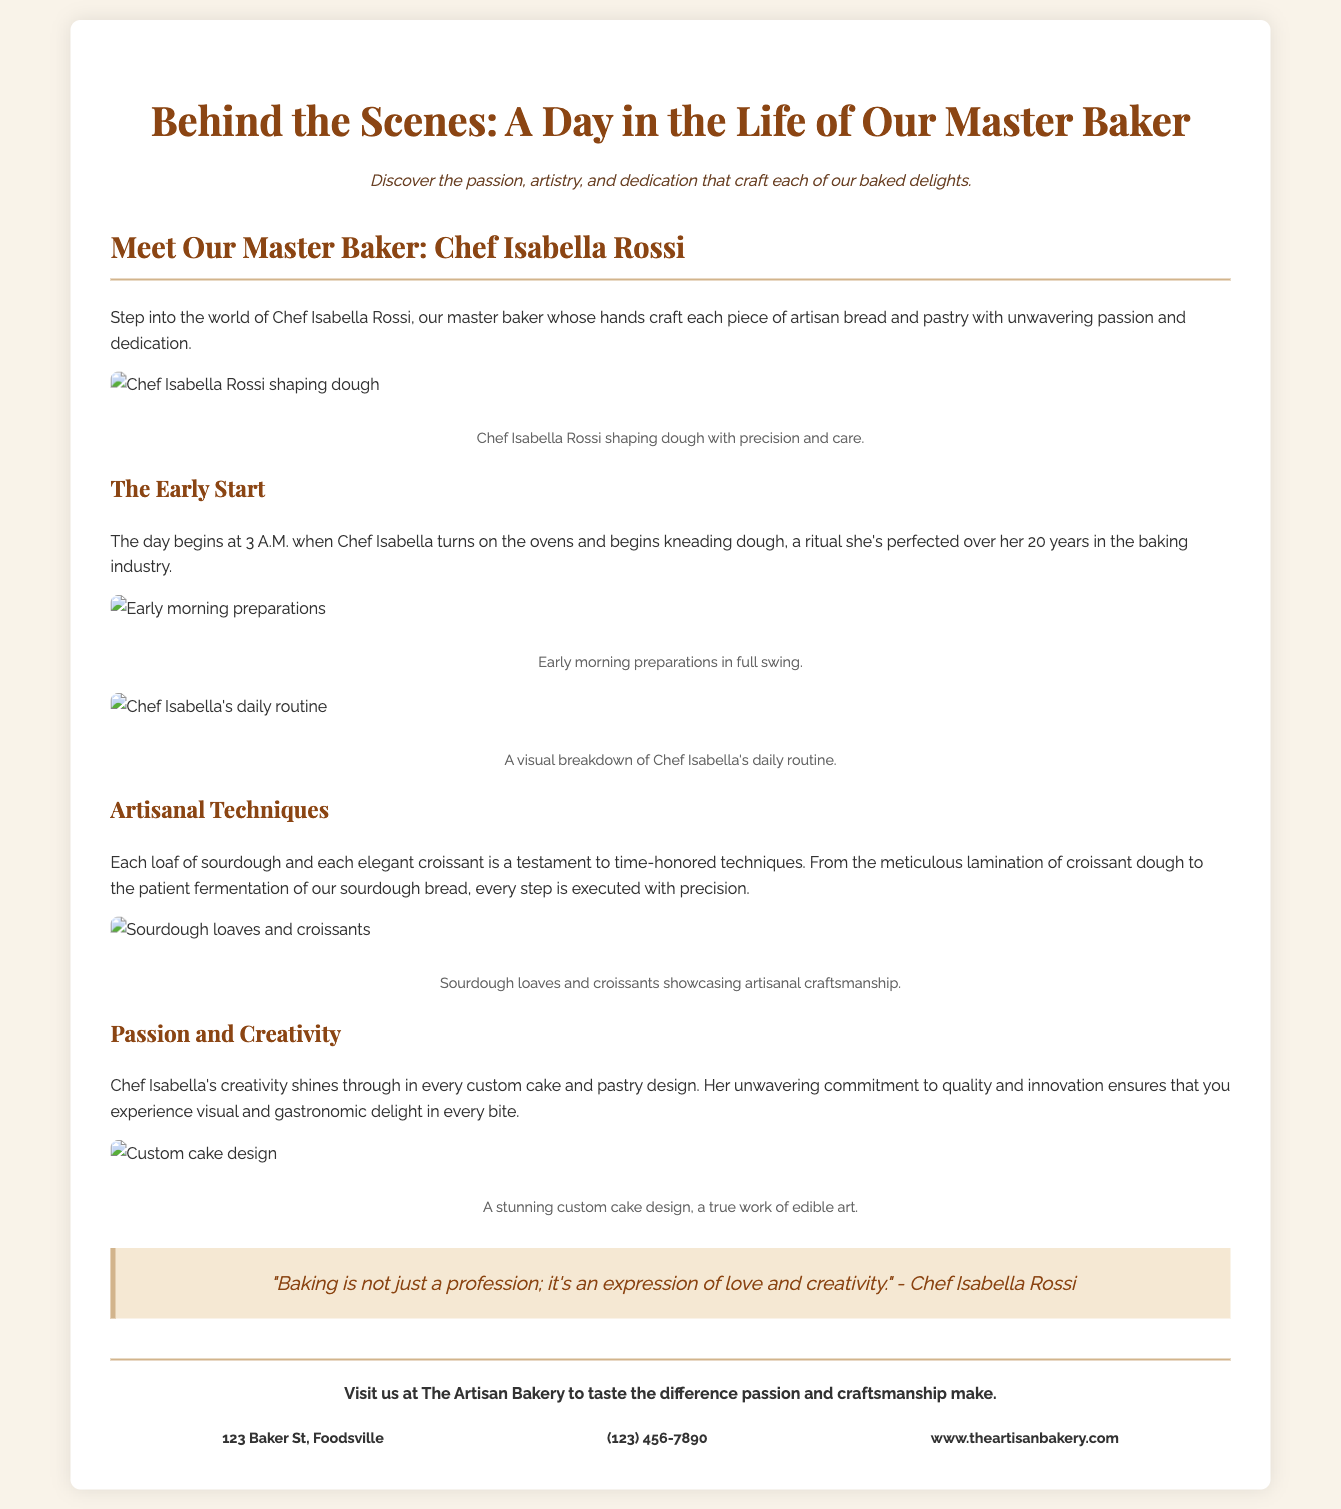What is the name of the master baker? The name of the master baker mentioned in the document is Chef Isabella Rossi.
Answer: Chef Isabella Rossi What time does Chef Isabella start her day? The document states that Chef Isabella starts her day at 3 A.M.
Answer: 3 A.M How many years of experience does Chef Isabella have? It is mentioned that Chef Isabella has 20 years of experience in the baking industry.
Answer: 20 years What type of bread is specifically mentioned in the document? The document mentions sourdough bread as one of the products crafted by the master baker.
Answer: Sourdough What is the main theme of the flyer? The main theme of the flyer is to showcase the daily life and techniques of the master baker, emphasizing craftsmanship.
Answer: Craftsmanship What does Chef Isabella refer to baking as? In the quote provided, Chef Isabella refers to baking as an expression of love and creativity.
Answer: An expression of love and creativity What type of design elements are used in the flyer? The design elements used in the flyer are described as elegant and minimalist.
Answer: Elegant and minimalist What is included in the visual breakdown of Chef Isabella's daily routine? The visual breakdown includes high-quality photographs and infographics detailing her daily routines and techniques.
Answer: High-quality photographs and infographics What address is listed in the contact information? The address listed in the contact information is 123 Baker St, Foodsville.
Answer: 123 Baker St, Foodsville 